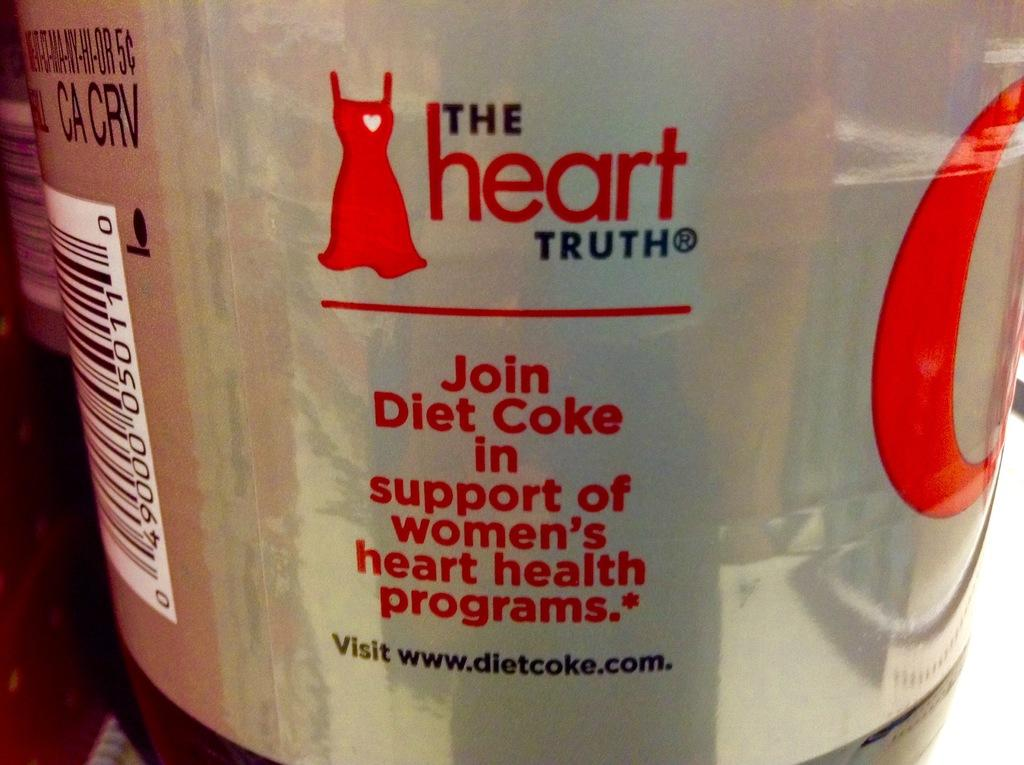<image>
Provide a brief description of the given image. A close up of a diet coke can. 